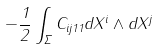Convert formula to latex. <formula><loc_0><loc_0><loc_500><loc_500>- \frac { 1 } { 2 } \int _ { \Sigma } C _ { i j 1 1 } d X ^ { i } \wedge d X ^ { j }</formula> 